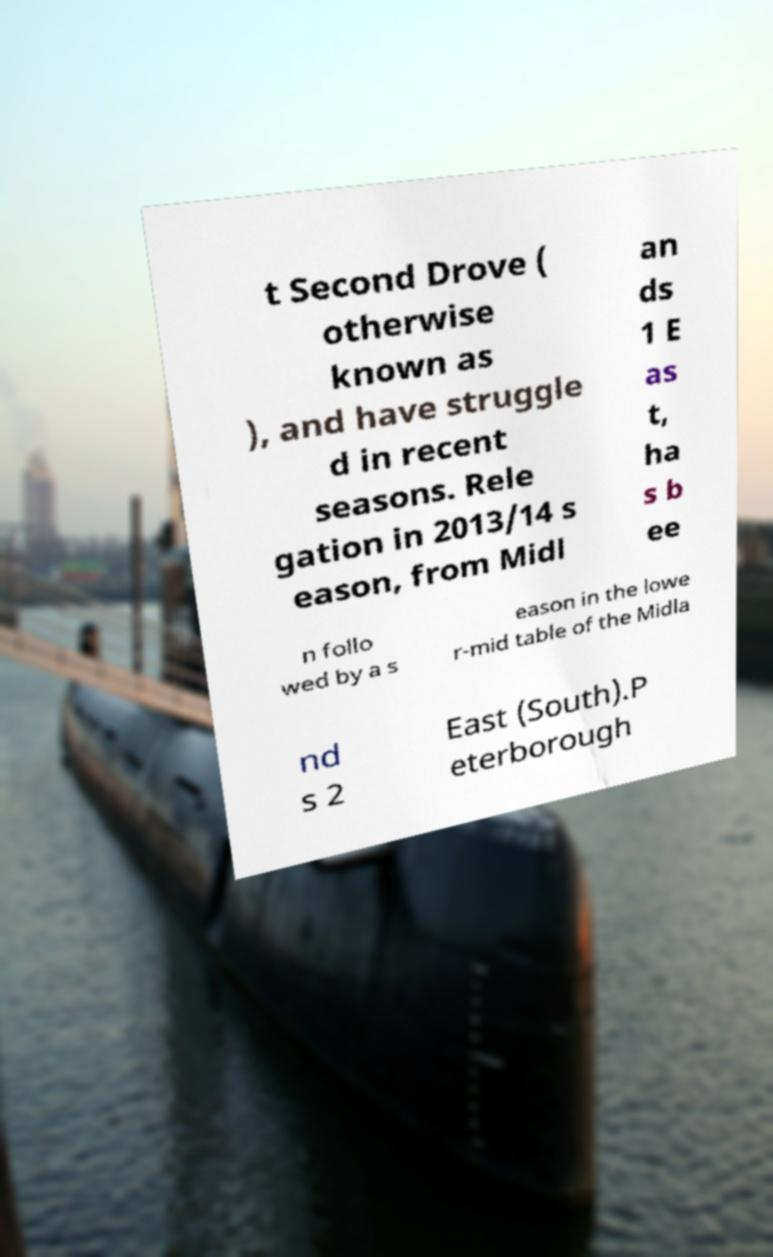I need the written content from this picture converted into text. Can you do that? t Second Drove ( otherwise known as ), and have struggle d in recent seasons. Rele gation in 2013/14 s eason, from Midl an ds 1 E as t, ha s b ee n follo wed by a s eason in the lowe r-mid table of the Midla nd s 2 East (South).P eterborough 